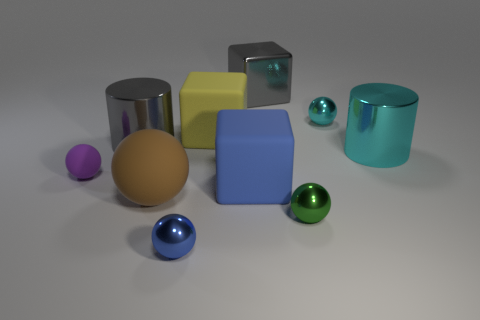There is a gray object that is on the left side of the big gray metallic object on the right side of the brown object; what is it made of?
Provide a succinct answer. Metal. Does the green shiny object have the same shape as the blue matte object?
Offer a terse response. No. What number of large objects are both in front of the gray metal block and to the right of the small blue ball?
Make the answer very short. 3. Are there the same number of tiny blue metal objects behind the small purple rubber ball and matte blocks to the left of the blue sphere?
Give a very brief answer. Yes. Do the rubber thing to the left of the brown sphere and the gray object left of the big sphere have the same size?
Provide a short and direct response. No. What material is the tiny sphere that is left of the large yellow block and to the right of the purple object?
Make the answer very short. Metal. Are there fewer large yellow matte cubes than small yellow matte cubes?
Give a very brief answer. No. What size is the gray metallic thing that is right of the metallic thing in front of the green ball?
Keep it short and to the point. Large. There is a large gray object to the left of the gray object to the right of the shiny cylinder that is to the left of the gray metal block; what is its shape?
Ensure brevity in your answer.  Cylinder. The other ball that is made of the same material as the purple ball is what color?
Make the answer very short. Brown. 